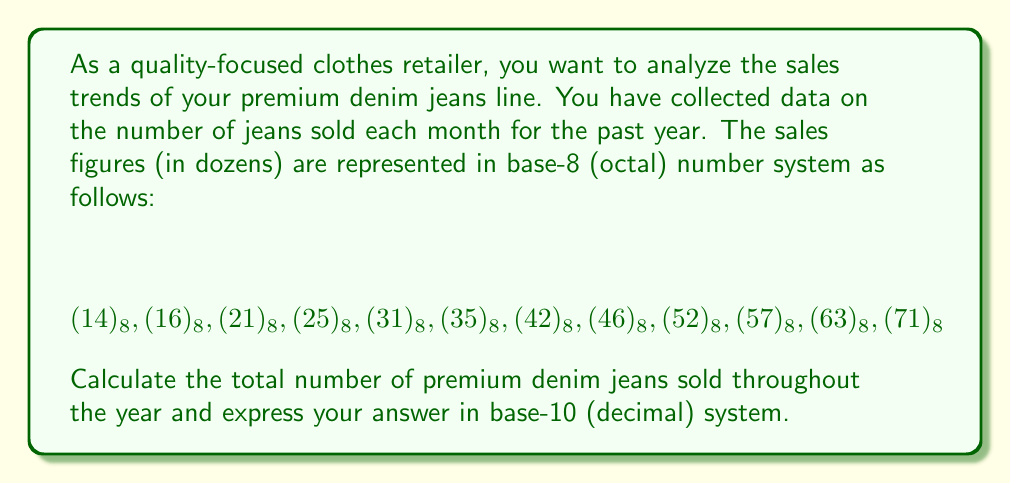Can you answer this question? To solve this problem, we need to follow these steps:

1. Convert each octal number to decimal (base-10).
2. Sum up all the converted numbers.
3. Express the final result in base-10.

Let's convert each number:

1. $(14)_8 = 1 \times 8^1 + 4 \times 8^0 = 8 + 4 = 12$
2. $(16)_8 = 1 \times 8^1 + 6 \times 8^0 = 8 + 6 = 14$
3. $(21)_8 = 2 \times 8^1 + 1 \times 8^0 = 16 + 1 = 17$
4. $(25)_8 = 2 \times 8^1 + 5 \times 8^0 = 16 + 5 = 21$
5. $(31)_8 = 3 \times 8^1 + 1 \times 8^0 = 24 + 1 = 25$
6. $(35)_8 = 3 \times 8^1 + 5 \times 8^0 = 24 + 5 = 29$
7. $(42)_8 = 4 \times 8^1 + 2 \times 8^0 = 32 + 2 = 34$
8. $(46)_8 = 4 \times 8^1 + 6 \times 8^0 = 32 + 6 = 38$
9. $(52)_8 = 5 \times 8^1 + 2 \times 8^0 = 40 + 2 = 42$
10. $(57)_8 = 5 \times 8^1 + 7 \times 8^0 = 40 + 7 = 47$
11. $(63)_8 = 6 \times 8^1 + 3 \times 8^0 = 48 + 3 = 51$
12. $(71)_8 = 7 \times 8^1 + 1 \times 8^0 = 56 + 1 = 57$

Now, let's sum up all these converted numbers:

$$12 + 14 + 17 + 21 + 25 + 29 + 34 + 38 + 42 + 47 + 51 + 57 = 387$$

Remember that each number represents dozens of jeans sold. So, to get the total number of jeans, we need to multiply by 12:

$$387 \times 12 = 4,644$$

Therefore, the total number of premium denim jeans sold throughout the year is 4,644.
Answer: 4,644 jeans 